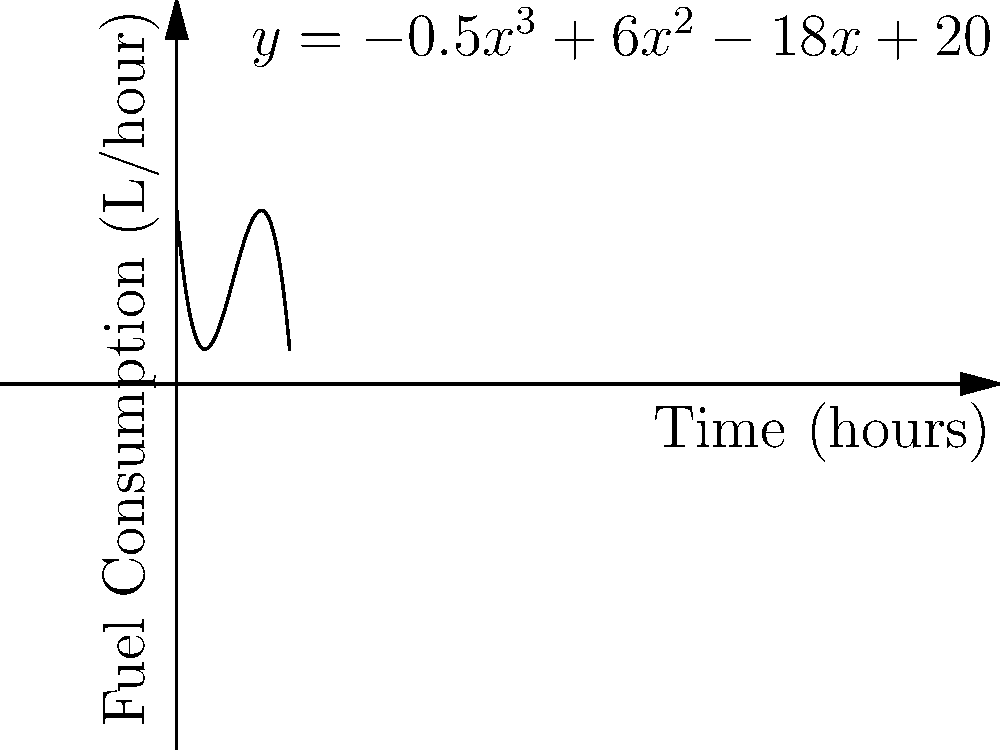The fuel consumption rate (in liters per hour) of a new Chinese military jet engine over time (in hours) is modeled by the polynomial function $y=-0.5x^3+6x^2-18x+20$, where $y$ represents the fuel consumption rate and $x$ represents the time since the engine was started. At what time does the engine reach its maximum fuel consumption rate? To find the time of maximum fuel consumption rate, we need to follow these steps:

1) The maximum point occurs where the derivative of the function is zero. Let's find the derivative:

   $f'(x) = -1.5x^2 + 12x - 18$

2) Set the derivative equal to zero and solve for x:

   $-1.5x^2 + 12x - 18 = 0$

3) This is a quadratic equation. We can solve it using the quadratic formula:
   $x = \frac{-b \pm \sqrt{b^2 - 4ac}}{2a}$

   Where $a=-1.5$, $b=12$, and $c=-18$

4) Plugging in these values:

   $x = \frac{-12 \pm \sqrt{12^2 - 4(-1.5)(-18)}}{2(-1.5)}$

5) Simplifying:

   $x = \frac{-12 \pm \sqrt{144 - 108}}{-3} = \frac{-12 \pm \sqrt{36}}{-3} = \frac{-12 \pm 6}{-3}$

6) This gives us two solutions:

   $x_1 = \frac{-12 + 6}{-3} = 2$
   $x_2 = \frac{-12 - 6}{-3} = 6$

7) To determine which of these is the maximum, we can check the second derivative:

   $f''(x) = -3x + 12$

8) At $x=2$: $f''(2) = -3(2) + 12 = 6 > 0$, indicating a minimum.
   At $x=6$: $f''(6) = -3(6) + 12 = -6 < 0$, indicating a maximum.

Therefore, the maximum fuel consumption rate occurs at $x=6$ hours.
Answer: 6 hours 